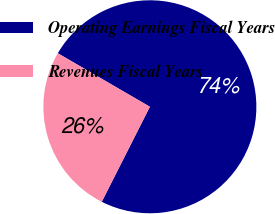<chart> <loc_0><loc_0><loc_500><loc_500><pie_chart><fcel>Operating Earnings Fiscal Years<fcel>Revenues Fiscal Years<nl><fcel>74.08%<fcel>25.92%<nl></chart> 